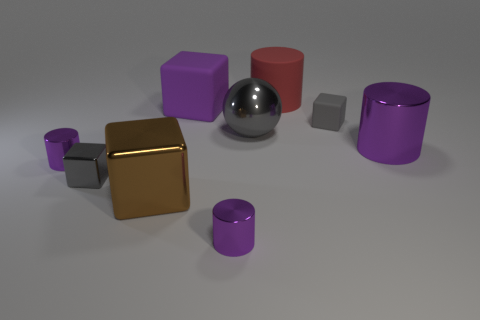Subtract all cyan balls. How many purple cylinders are left? 3 Subtract all cyan blocks. Subtract all blue balls. How many blocks are left? 4 Add 1 big metal cubes. How many objects exist? 10 Subtract all spheres. How many objects are left? 8 Subtract all purple shiny blocks. Subtract all metal balls. How many objects are left? 8 Add 4 small metallic cubes. How many small metallic cubes are left? 5 Add 8 purple cubes. How many purple cubes exist? 9 Subtract 0 gray cylinders. How many objects are left? 9 